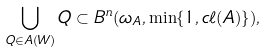Convert formula to latex. <formula><loc_0><loc_0><loc_500><loc_500>\bigcup _ { Q \in A ( W ) } Q \subset B ^ { n } ( \omega _ { A } , \min \{ 1 , c \ell ( A ) \} ) ,</formula> 